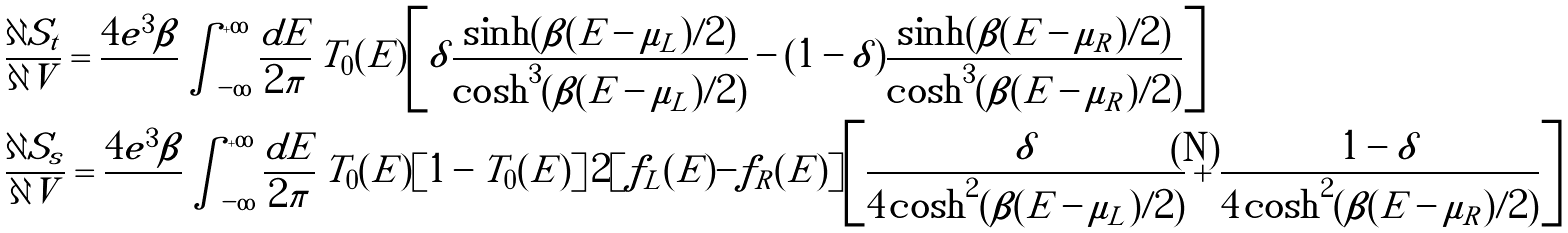Convert formula to latex. <formula><loc_0><loc_0><loc_500><loc_500>& \frac { \partial S _ { t } } { \partial V } = \frac { 4 e ^ { 3 } \beta } { } \int _ { - \infty } ^ { + \infty } \frac { d E } { 2 \pi } \, T _ { 0 } ( E ) \left [ \delta \frac { \sinh ( \beta ( E - \mu _ { L } ) / 2 ) } { \cosh ^ { 3 } ( \beta ( E - \mu _ { L } ) / 2 ) } - ( 1 - \delta ) \frac { \sinh ( \beta ( E - \mu _ { R } ) / 2 ) } { \cosh ^ { 3 } ( \beta ( E - \mu _ { R } ) / 2 ) } \right ] \\ & \frac { \partial S _ { s } } { \partial V } = \frac { 4 e ^ { 3 } \beta } { } \int _ { - \infty } ^ { + \infty } \frac { d E } { 2 \pi } \, T _ { 0 } ( E ) [ 1 - T _ { 0 } ( E ) ] \, 2 [ f _ { L } ( E ) - f _ { R } ( E ) ] \left [ \frac { \delta } { 4 \cosh ^ { 2 } ( \beta ( E - \mu _ { L } ) / 2 ) } + \frac { 1 - \delta } { 4 \cosh ^ { 2 } ( \beta ( E - \mu _ { R } ) / 2 ) } \right ]</formula> 